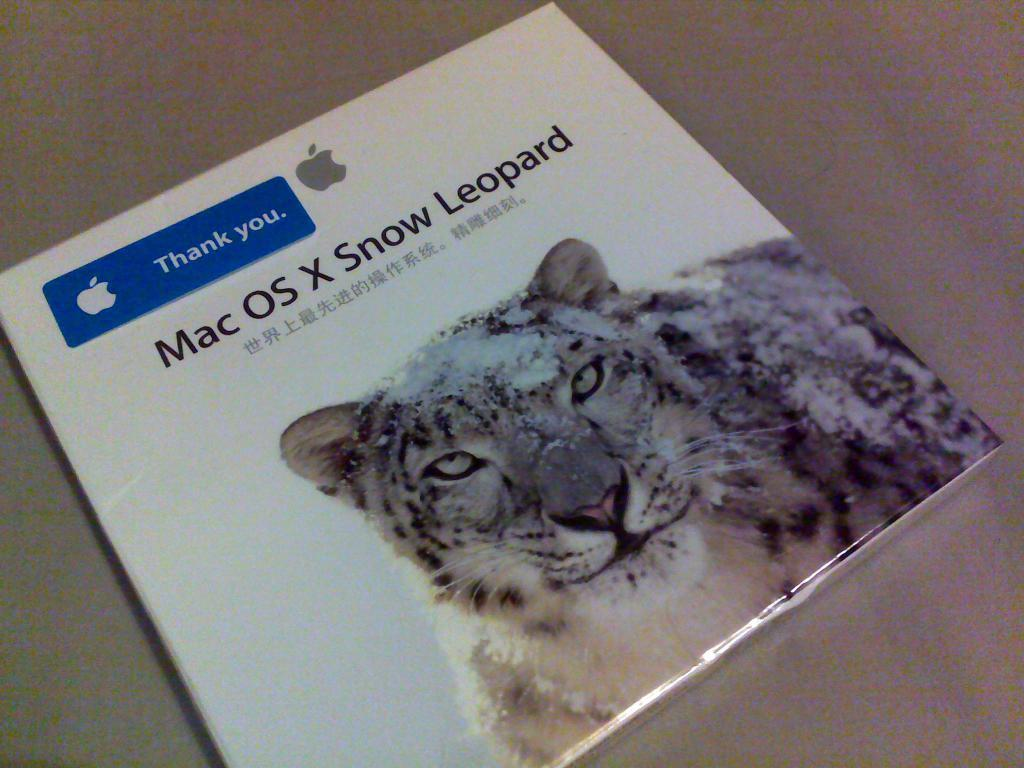What is the main object in the image that resembles a book? There is an object in the image that resembles a book. What can be found on the book's surface? The book has text and an image on it. What type of trousers is your dad wearing in the morning in the image? There is no person, including a dad, present in the image, so it is not possible to determine what type of trousers they might be wearing in the morning. 